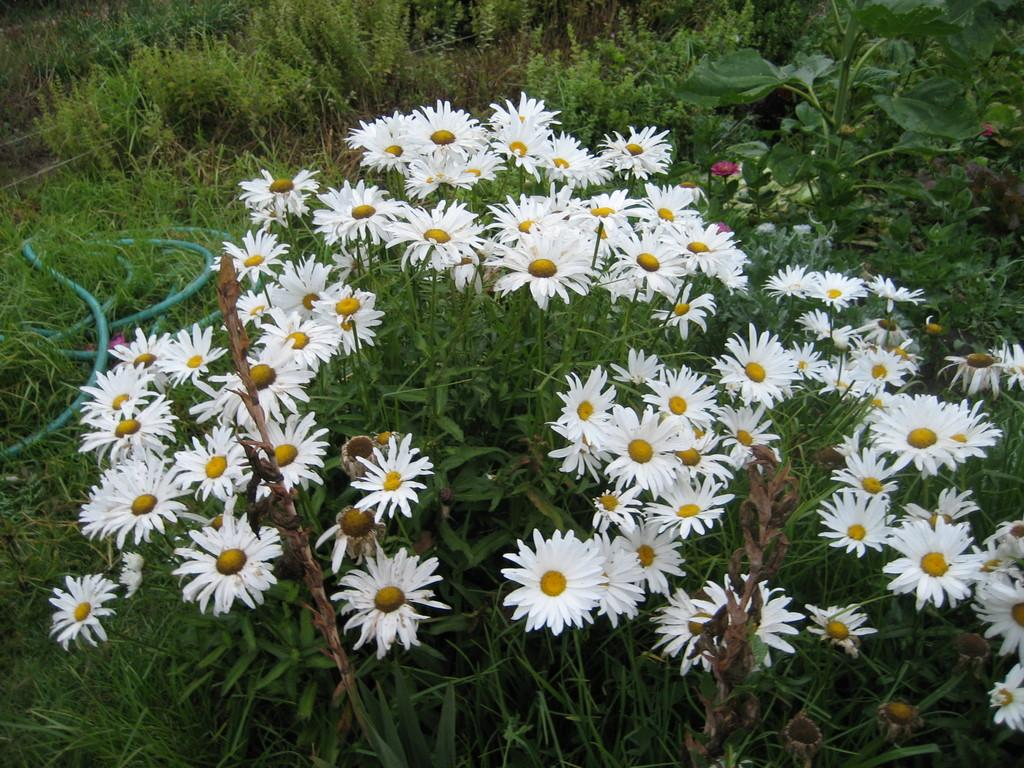What type of flora can be seen in the image? There are flowers and plants in the image. Can you describe the tube in the image? Yes, there is a tube in the image. What type of wrist can be seen on the hill in the image? There is no wrist or hill present in the image; it features flowers, plants, and a tube. 